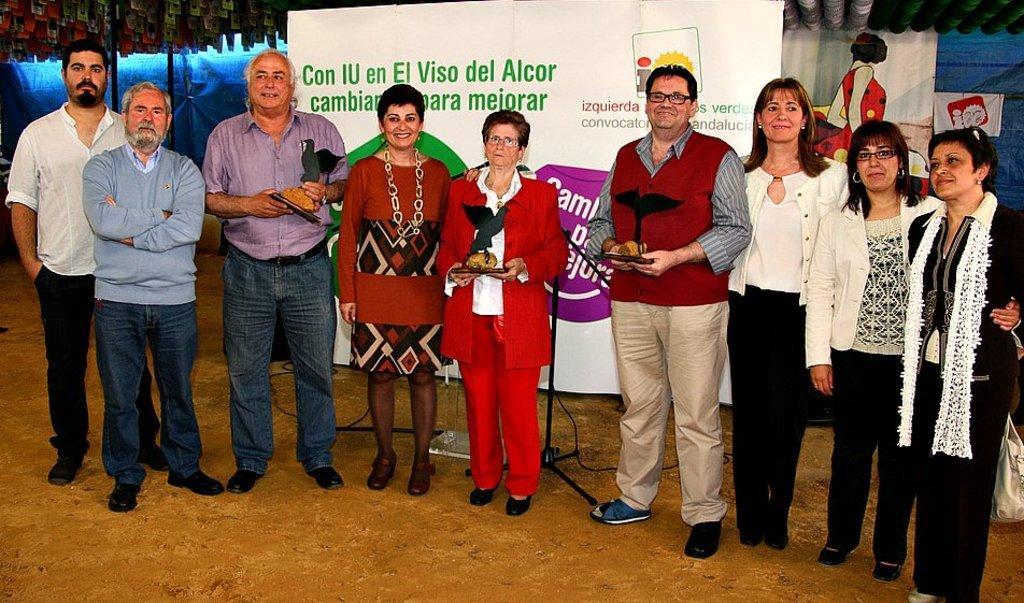Please provide a concise description of this image. In this image I can see there are few persons standing on the floor and back side of them I can see a hoarding board and some text written on that board. And I can see blue color fence visible on the right side 